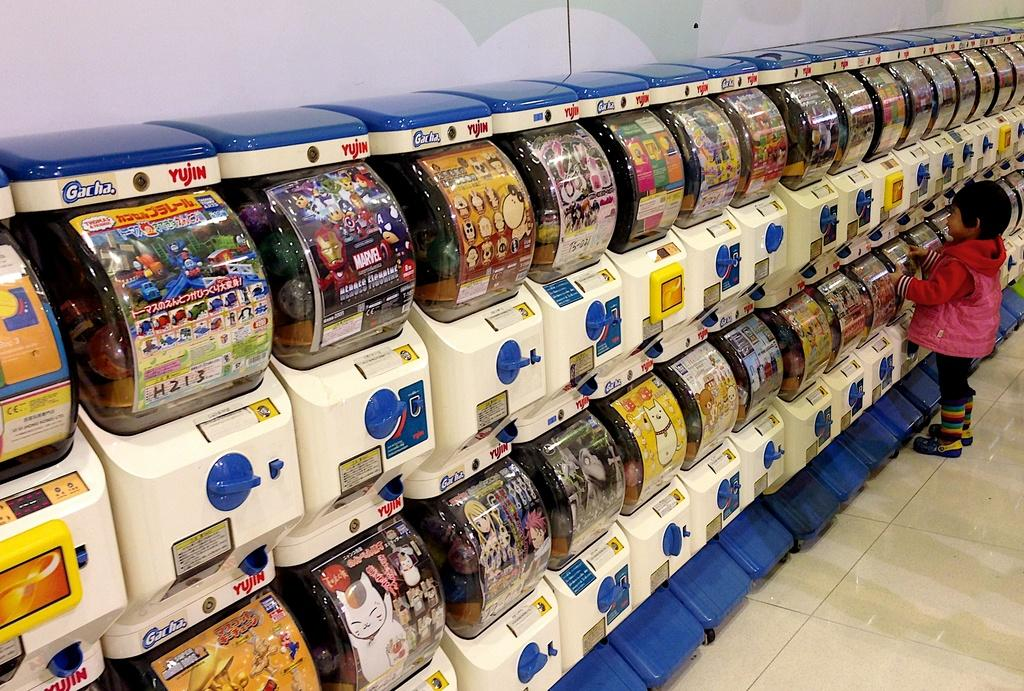What type of objects are present in the image? There are toy machines in the image. What is the kid doing in the image? A kid is standing in front of one of the machines. What is the kid wearing in the image? The kid is wearing a pink jacket. What type of cable can be seen connecting the toy machines in the image? There is no cable connecting the toy machines in the image. What kind of lumber is visible in the background of the image? There is no lumber present in the image. 